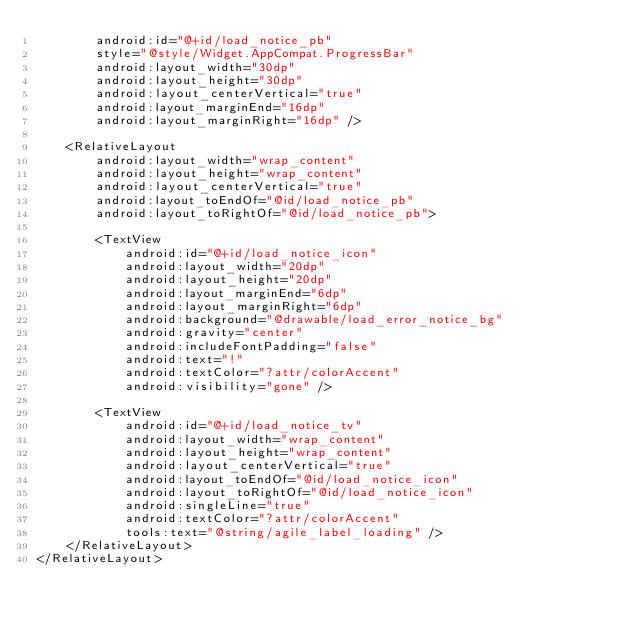<code> <loc_0><loc_0><loc_500><loc_500><_XML_>        android:id="@+id/load_notice_pb"
        style="@style/Widget.AppCompat.ProgressBar"
        android:layout_width="30dp"
        android:layout_height="30dp"
        android:layout_centerVertical="true"
        android:layout_marginEnd="16dp"
        android:layout_marginRight="16dp" />

    <RelativeLayout
        android:layout_width="wrap_content"
        android:layout_height="wrap_content"
        android:layout_centerVertical="true"
        android:layout_toEndOf="@id/load_notice_pb"
        android:layout_toRightOf="@id/load_notice_pb">

        <TextView
            android:id="@+id/load_notice_icon"
            android:layout_width="20dp"
            android:layout_height="20dp"
            android:layout_marginEnd="6dp"
            android:layout_marginRight="6dp"
            android:background="@drawable/load_error_notice_bg"
            android:gravity="center"
            android:includeFontPadding="false"
            android:text="!"
            android:textColor="?attr/colorAccent"
            android:visibility="gone" />

        <TextView
            android:id="@+id/load_notice_tv"
            android:layout_width="wrap_content"
            android:layout_height="wrap_content"
            android:layout_centerVertical="true"
            android:layout_toEndOf="@id/load_notice_icon"
            android:layout_toRightOf="@id/load_notice_icon"
            android:singleLine="true"
            android:textColor="?attr/colorAccent"
            tools:text="@string/agile_label_loading" />
    </RelativeLayout>
</RelativeLayout></code> 